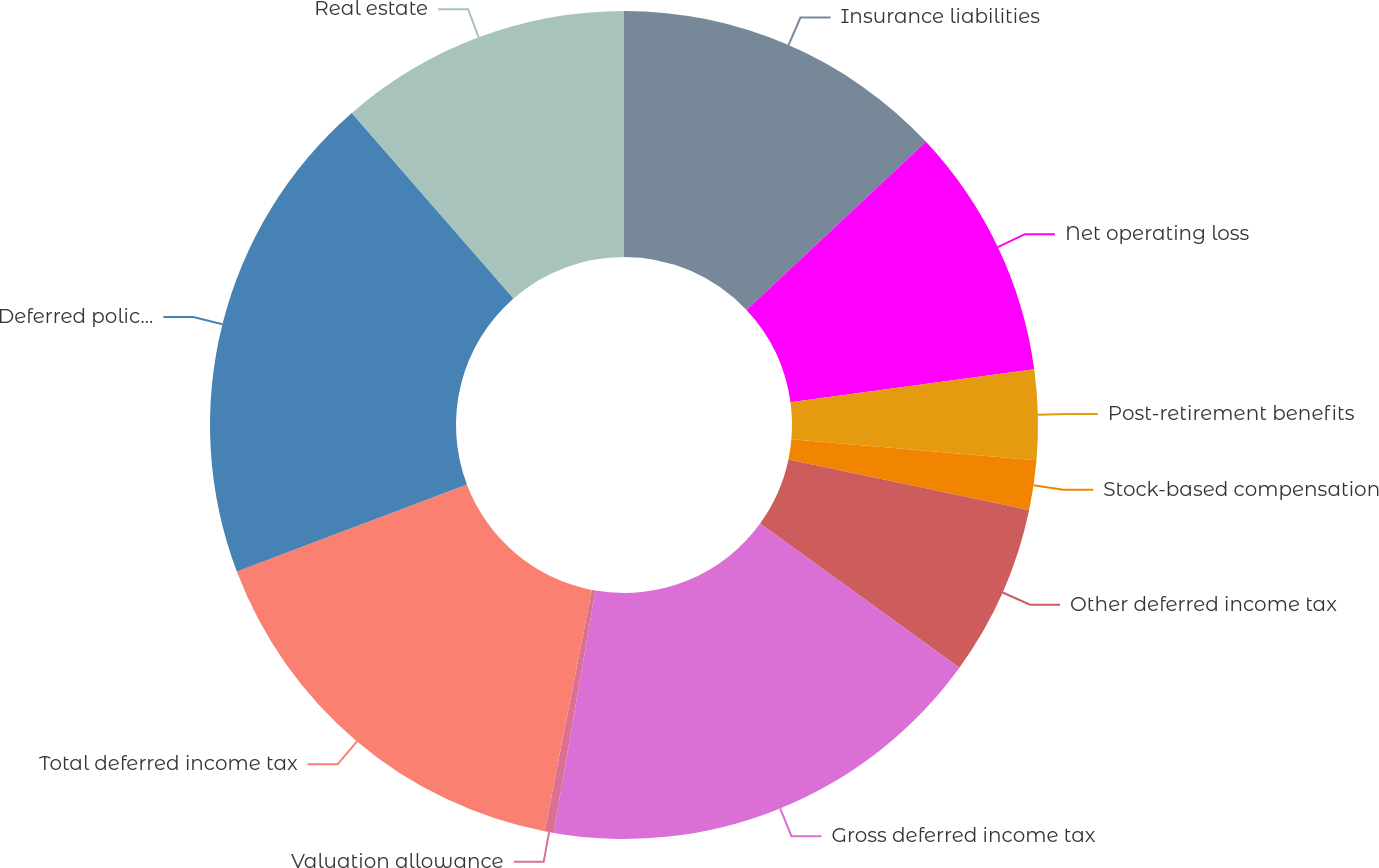Convert chart to OTSL. <chart><loc_0><loc_0><loc_500><loc_500><pie_chart><fcel>Insurance liabilities<fcel>Net operating loss<fcel>Post-retirement benefits<fcel>Stock-based compensation<fcel>Other deferred income tax<fcel>Gross deferred income tax<fcel>Valuation allowance<fcel>Total deferred income tax<fcel>Deferred policy acquisition<fcel>Real estate<nl><fcel>13.01%<fcel>9.84%<fcel>3.51%<fcel>1.93%<fcel>6.68%<fcel>17.75%<fcel>0.35%<fcel>16.17%<fcel>19.34%<fcel>11.42%<nl></chart> 